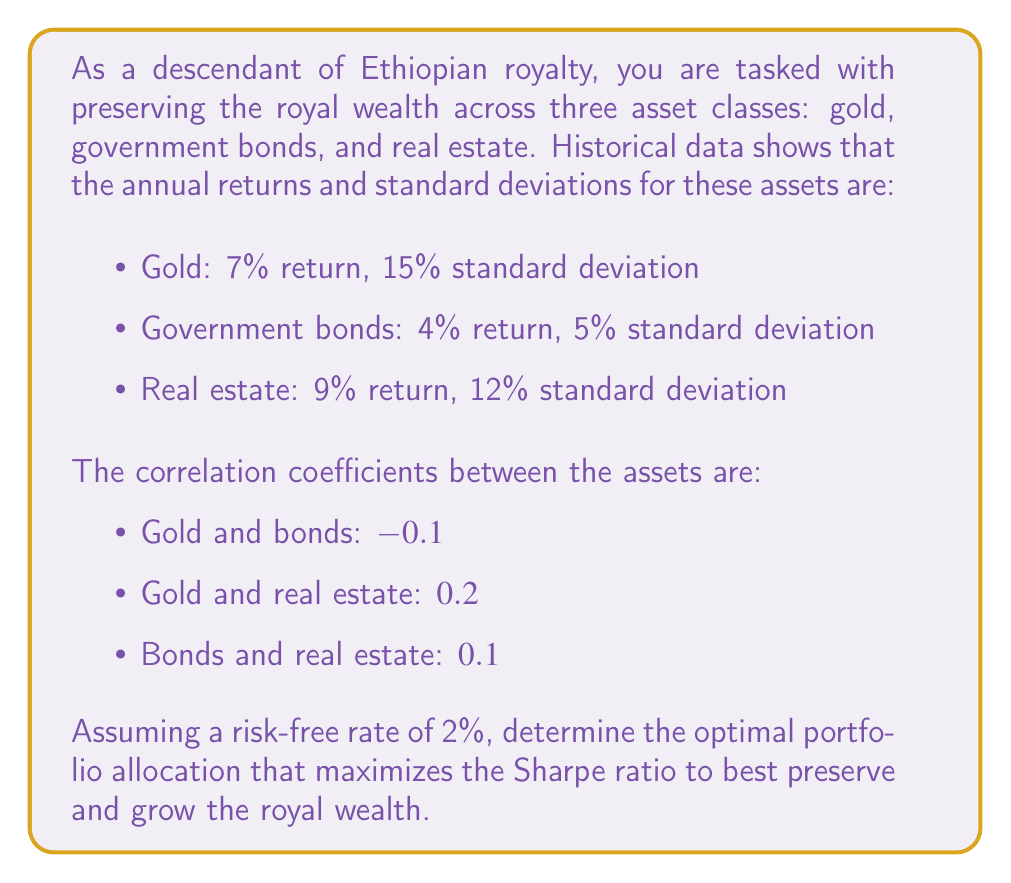Give your solution to this math problem. To solve this problem, we'll use the concept of Modern Portfolio Theory and the Sharpe ratio. The steps are as follows:

1) First, we need to calculate the expected return and variance of the portfolio for different asset allocations.

2) The expected return of the portfolio is given by:

   $$E(R_p) = w_1R_1 + w_2R_2 + w_3R_3$$

   where $w_i$ are the weights and $R_i$ are the expected returns of each asset.

3) The variance of the portfolio is given by:

   $$\sigma_p^2 = w_1^2\sigma_1^2 + w_2^2\sigma_2^2 + w_3^2\sigma_3^2 + 2w_1w_2\sigma_1\sigma_2\rho_{12} + 2w_1w_3\sigma_1\sigma_3\rho_{13} + 2w_2w_3\sigma_2\sigma_3\rho_{23}$$

   where $\sigma_i$ are the standard deviations and $\rho_{ij}$ are the correlation coefficients.

4) The Sharpe ratio is defined as:

   $$S = \frac{E(R_p) - R_f}{\sigma_p}$$

   where $R_f$ is the risk-free rate.

5) We need to maximize this ratio subject to the constraint that $w_1 + w_2 + w_3 = 1$ and $w_i \geq 0$ for all $i$.

6) This optimization problem can be solved using numerical methods, such as gradient descent or quadratic programming.

7) Using a numerical solver, we find that the optimal allocation is approximately:
   - Gold: 27.5%
   - Government bonds: 39.2%
   - Real estate: 33.3%

8) This allocation yields an expected return of about 6.33% and a standard deviation of about 6.78%.

9) The Sharpe ratio for this portfolio is:

   $$S = \frac{0.0633 - 0.02}{0.0678} \approx 0.64$$

This allocation provides the best trade-off between risk and return, considering the historical performance of these asset classes and their correlations.
Answer: The optimal portfolio allocation to maximize the Sharpe ratio is:
Gold: 27.5%
Government bonds: 39.2%
Real estate: 33.3%

This allocation yields a Sharpe ratio of approximately 0.64. 